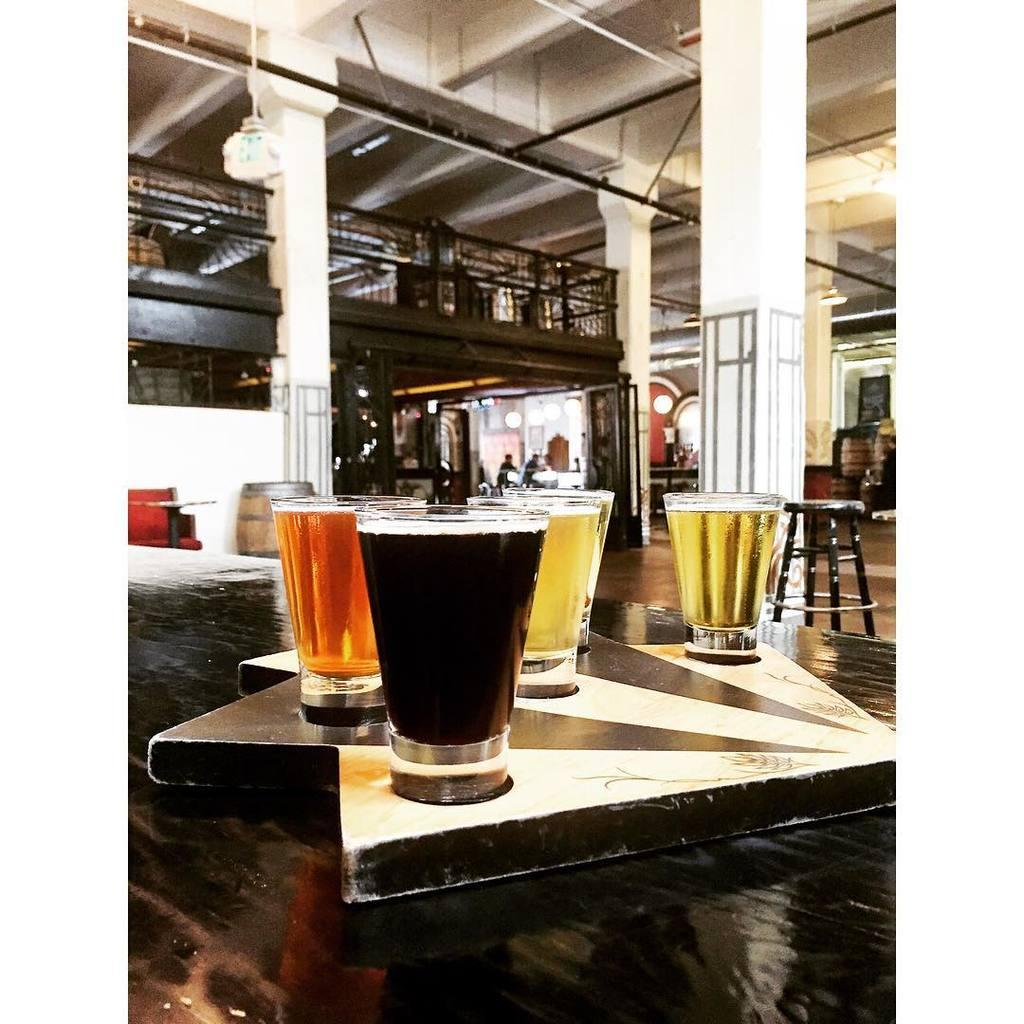What objects are in the image? There are glasses in the image. What is inside the glasses? The glasses contain wine. What type of collar can be seen on the wine in the image? There is no collar present on the wine in the image. 